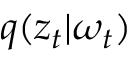<formula> <loc_0><loc_0><loc_500><loc_500>q ( z _ { t } | \omega _ { t } )</formula> 